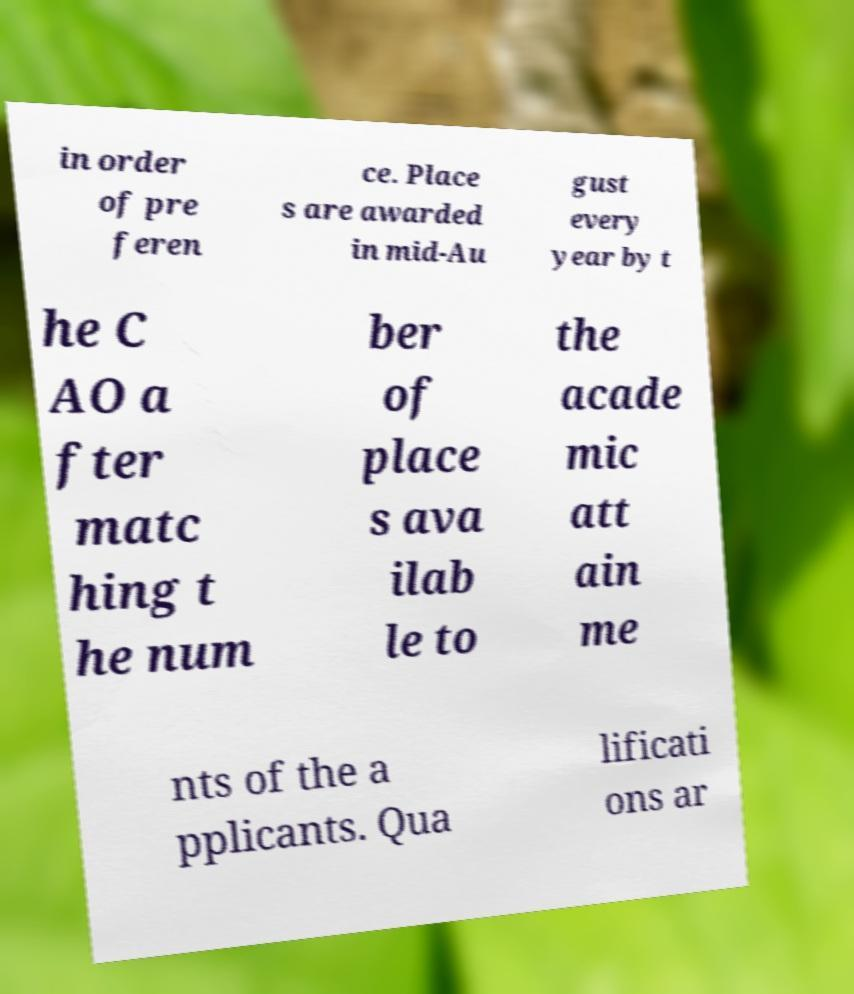Can you read and provide the text displayed in the image?This photo seems to have some interesting text. Can you extract and type it out for me? in order of pre feren ce. Place s are awarded in mid-Au gust every year by t he C AO a fter matc hing t he num ber of place s ava ilab le to the acade mic att ain me nts of the a pplicants. Qua lificati ons ar 